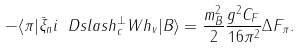Convert formula to latex. <formula><loc_0><loc_0><loc_500><loc_500>- \langle \pi | \bar { \xi } _ { n } i \ D s l a s h _ { c } ^ { \perp } W h _ { v } | B \rangle = \frac { m _ { B } ^ { 2 } } { 2 } \frac { g ^ { 2 } C _ { F } } { 1 6 \pi ^ { 2 } } \Delta F _ { \pi } .</formula> 